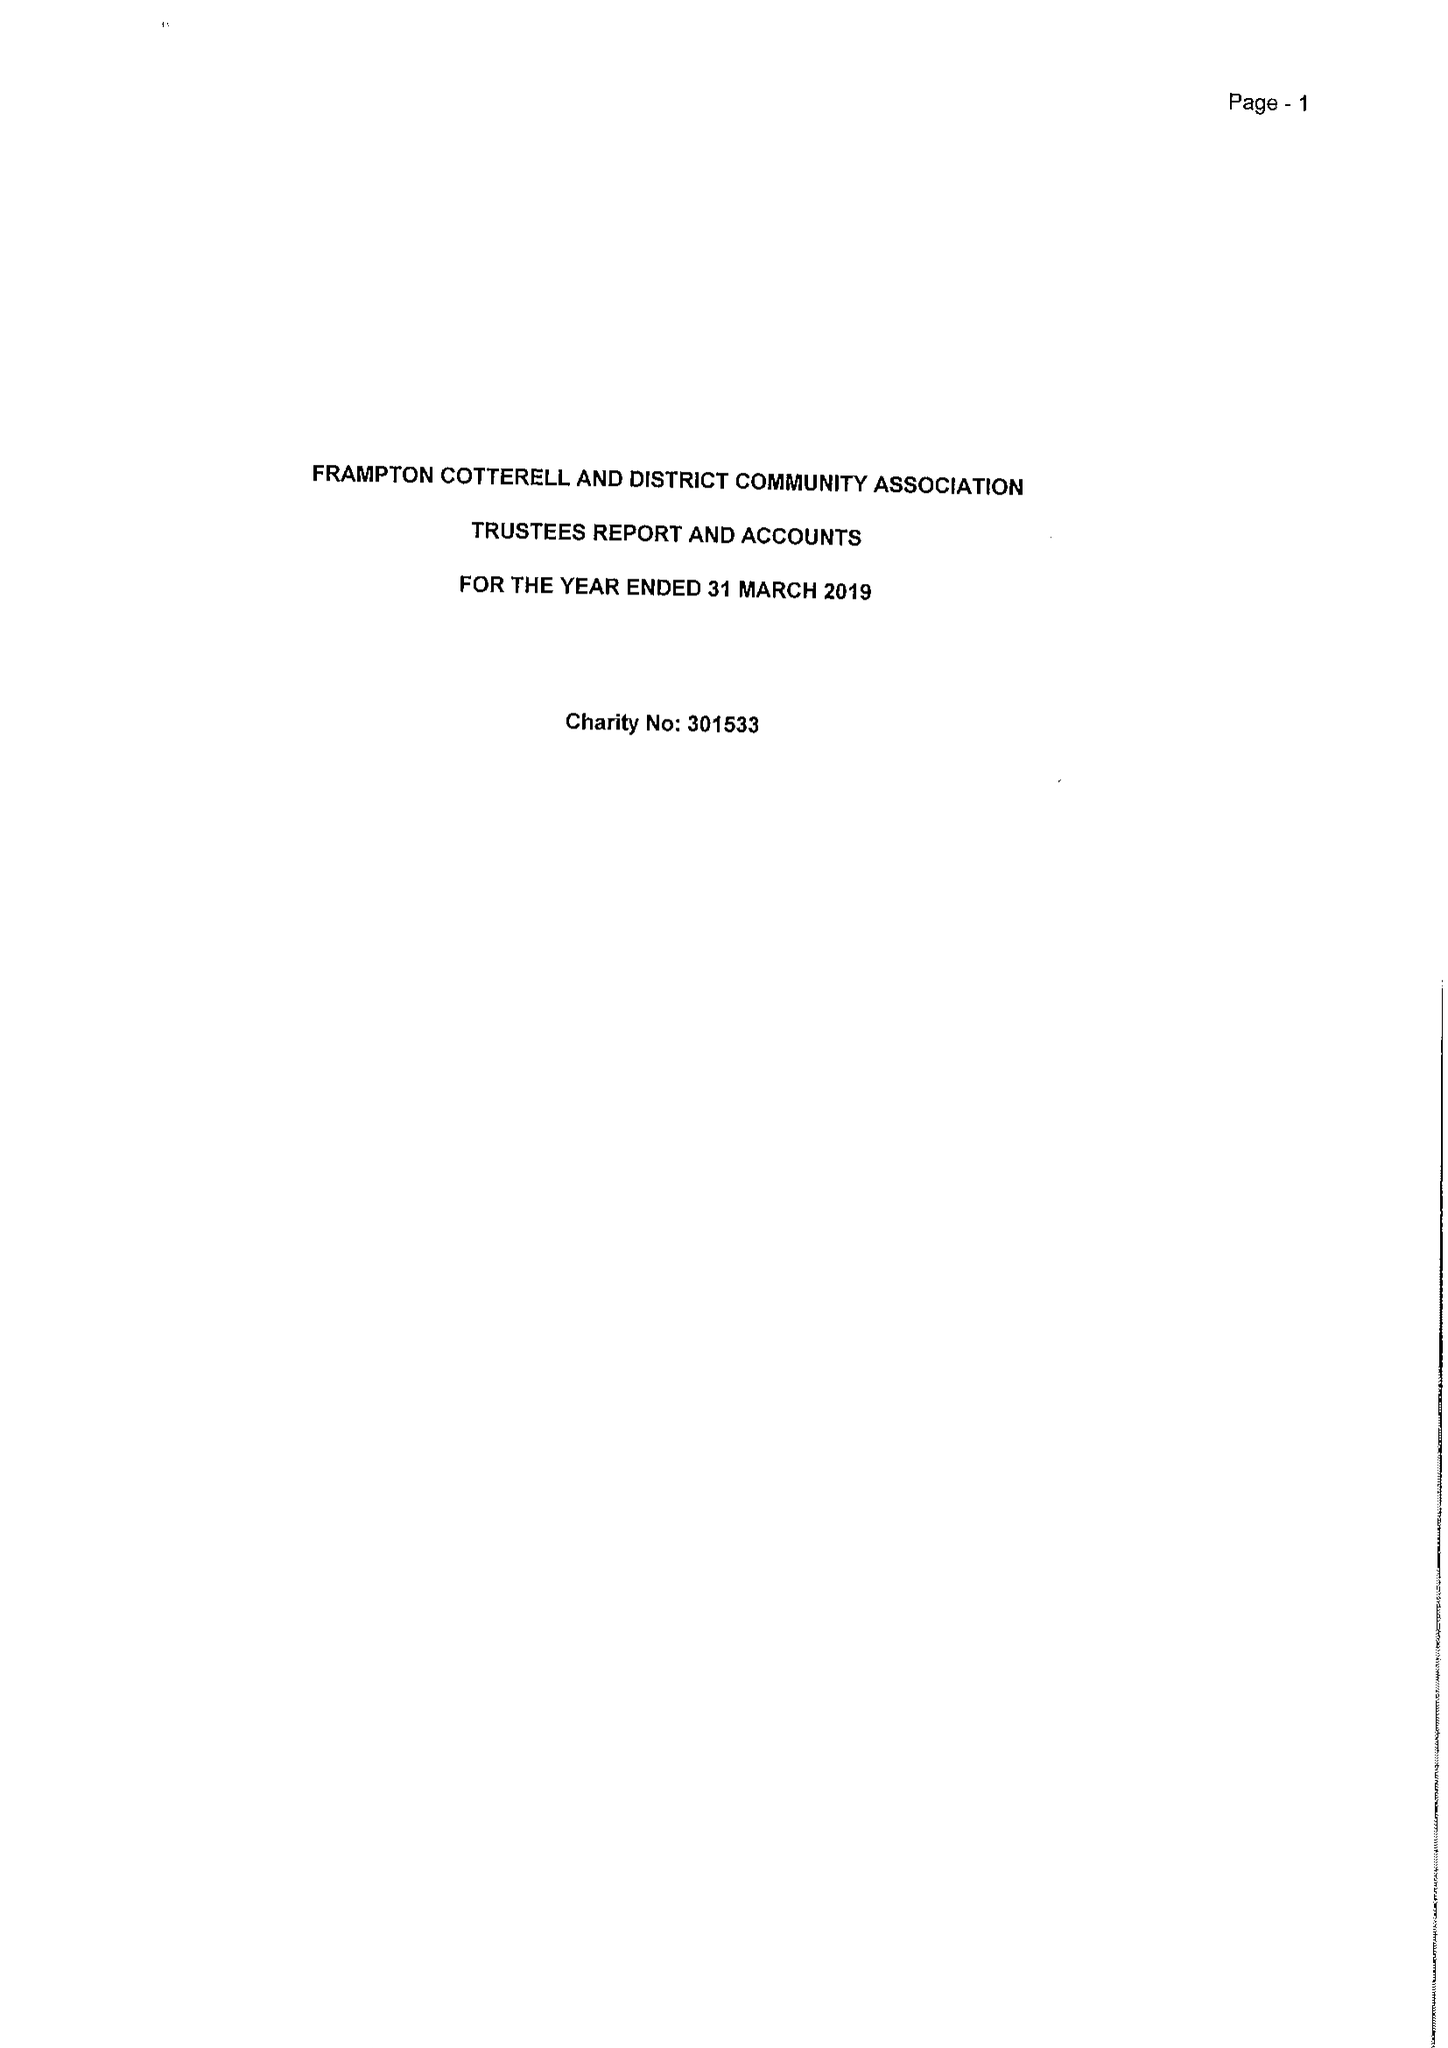What is the value for the report_date?
Answer the question using a single word or phrase. 2019-03-31 